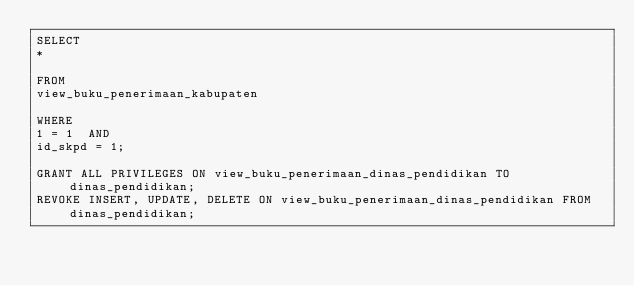Convert code to text. <code><loc_0><loc_0><loc_500><loc_500><_SQL_>SELECT
*

FROM
view_buku_penerimaan_kabupaten

WHERE
1 = 1  AND
id_skpd = 1;

GRANT ALL PRIVILEGES ON view_buku_penerimaan_dinas_pendidikan TO dinas_pendidikan;
REVOKE INSERT, UPDATE, DELETE ON view_buku_penerimaan_dinas_pendidikan FROM dinas_pendidikan;
</code> 